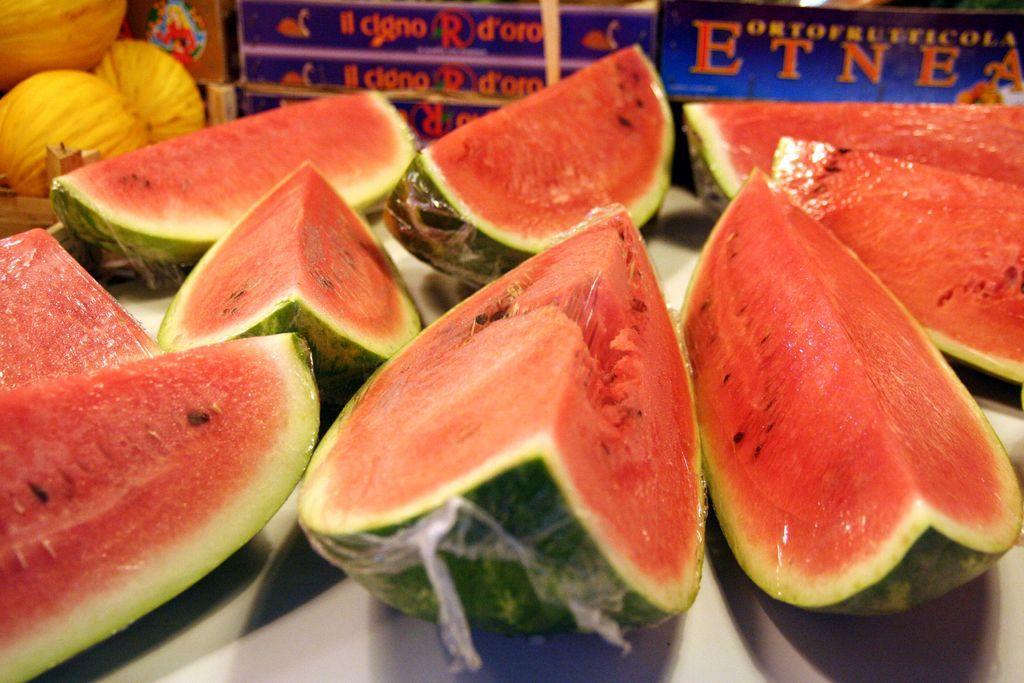Can you describe this image briefly? In this image we can see some food items and behind that we can see some text written. 